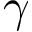Convert formula to latex. <formula><loc_0><loc_0><loc_500><loc_500>\gamma</formula> 